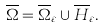Convert formula to latex. <formula><loc_0><loc_0><loc_500><loc_500>\overline { \Omega } = \overline { \Omega } _ { \varepsilon } \cup \overline { H } _ { \varepsilon } .</formula> 